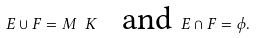Convert formula to latex. <formula><loc_0><loc_0><loc_500><loc_500>E \cup F = M \ K \text { \ \ and } E \cap F = \phi .</formula> 